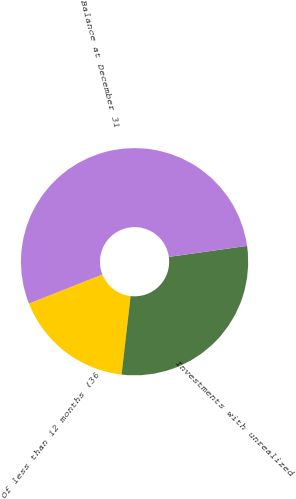Convert chart to OTSL. <chart><loc_0><loc_0><loc_500><loc_500><pie_chart><fcel>Of less than 12 months (36<fcel>Investments with unrealized<fcel>Balance at December 31<nl><fcel>17.17%<fcel>29.05%<fcel>53.77%<nl></chart> 